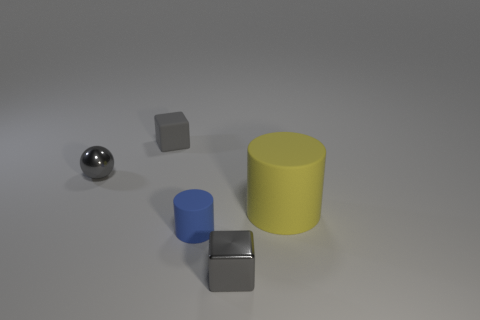Are there any matte things of the same size as the yellow cylinder?
Offer a terse response. No. What number of gray objects are either big cylinders or cubes?
Offer a very short reply. 2. How many metallic objects are the same color as the tiny rubber cube?
Your response must be concise. 2. Is there any other thing that is the same shape as the small blue matte thing?
Provide a short and direct response. Yes. What number of blocks are either tiny objects or small gray metallic things?
Offer a very short reply. 2. What is the color of the cylinder right of the gray metal cube?
Offer a very short reply. Yellow. What shape is the other matte thing that is the same size as the blue thing?
Offer a very short reply. Cube. What number of gray things are in front of the yellow rubber cylinder?
Give a very brief answer. 1. What number of objects are either tiny yellow matte objects or blue cylinders?
Offer a very short reply. 1. There is a matte thing that is on the left side of the yellow cylinder and in front of the tiny matte cube; what shape is it?
Give a very brief answer. Cylinder. 